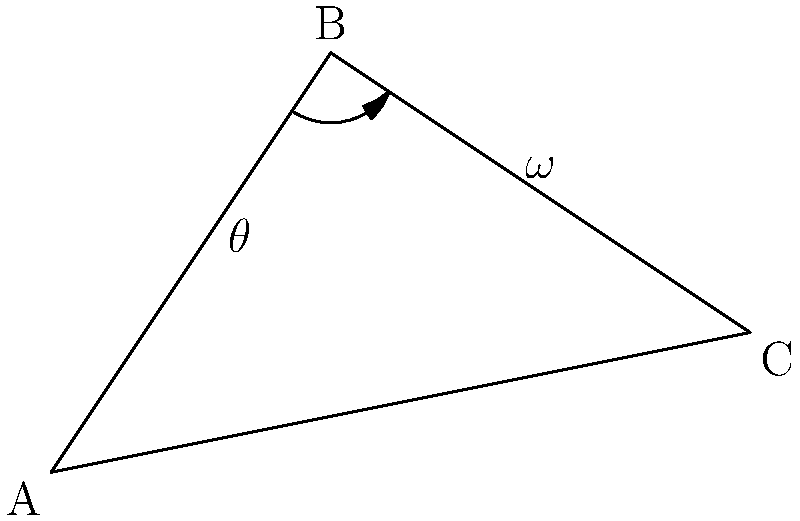In a stick figure model of a running athlete, the hip, knee, and ankle joints form a triangle ABC as shown. Given that the angle $\theta$ at B (knee) is 60°, and the angular velocity $\omega$ of the thigh (AB) is 2 rad/s, calculate the angular velocity of the shank (BC) relative to the thigh. To solve this problem, we'll use the concept of relative angular velocity in a kinematic chain. Let's break it down step-by-step:

1) In a kinematic chain, the angular velocity of a distal segment relative to a proximal segment is the difference between their absolute angular velocities.

2) Let $\omega_{AB}$ be the angular velocity of AB (thigh), $\omega_{BC}$ be the angular velocity of BC (shank), and $\omega_{BC/AB}$ be the angular velocity of BC relative to AB.

3) The relationship is: $\omega_{BC/AB} = \omega_{BC} - \omega_{AB}$

4) We're given $\omega_{AB} = 2$ rad/s

5) To find $\omega_{BC}$, we need to use the law of cosines for angular velocities:

   $\omega_{BC} = \omega_{AB} \cdot \frac{\sin(\theta)}{\sin(180°-\theta)} = \omega_{AB} \cdot \frac{\sin(\theta)}{\sin(\theta)} = \omega_{AB}$

6) Therefore, $\omega_{BC} = 2$ rad/s

7) Now we can calculate $\omega_{BC/AB}$:

   $\omega_{BC/AB} = \omega_{BC} - \omega_{AB} = 2 - 2 = 0$ rad/s

This means the shank is not rotating relative to the thigh, despite both segments rotating in the global reference frame.
Answer: 0 rad/s 